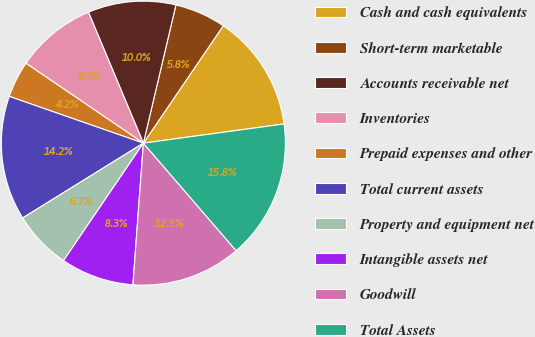Convert chart to OTSL. <chart><loc_0><loc_0><loc_500><loc_500><pie_chart><fcel>Cash and cash equivalents<fcel>Short-term marketable<fcel>Accounts receivable net<fcel>Inventories<fcel>Prepaid expenses and other<fcel>Total current assets<fcel>Property and equipment net<fcel>Intangible assets net<fcel>Goodwill<fcel>Total Assets<nl><fcel>13.33%<fcel>5.83%<fcel>10.0%<fcel>9.17%<fcel>4.17%<fcel>14.17%<fcel>6.67%<fcel>8.33%<fcel>12.5%<fcel>15.83%<nl></chart> 